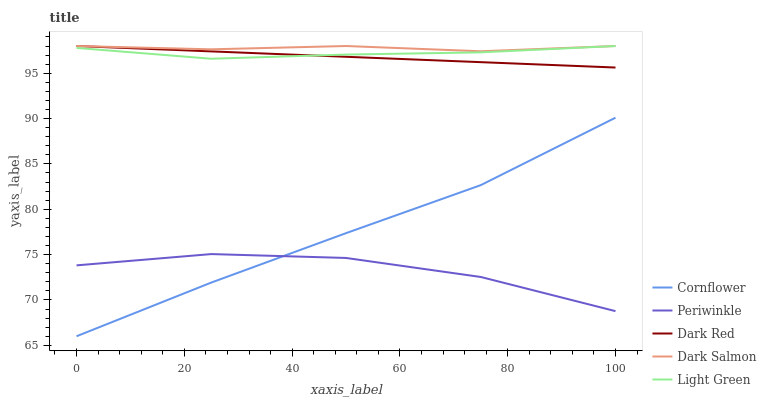Does Periwinkle have the minimum area under the curve?
Answer yes or no. Yes. Does Dark Salmon have the maximum area under the curve?
Answer yes or no. Yes. Does Dark Salmon have the minimum area under the curve?
Answer yes or no. No. Does Periwinkle have the maximum area under the curve?
Answer yes or no. No. Is Dark Red the smoothest?
Answer yes or no. Yes. Is Periwinkle the roughest?
Answer yes or no. Yes. Is Dark Salmon the smoothest?
Answer yes or no. No. Is Dark Salmon the roughest?
Answer yes or no. No. Does Cornflower have the lowest value?
Answer yes or no. Yes. Does Periwinkle have the lowest value?
Answer yes or no. No. Does Dark Red have the highest value?
Answer yes or no. Yes. Does Periwinkle have the highest value?
Answer yes or no. No. Is Cornflower less than Light Green?
Answer yes or no. Yes. Is Light Green greater than Cornflower?
Answer yes or no. Yes. Does Dark Red intersect Dark Salmon?
Answer yes or no. Yes. Is Dark Red less than Dark Salmon?
Answer yes or no. No. Is Dark Red greater than Dark Salmon?
Answer yes or no. No. Does Cornflower intersect Light Green?
Answer yes or no. No. 